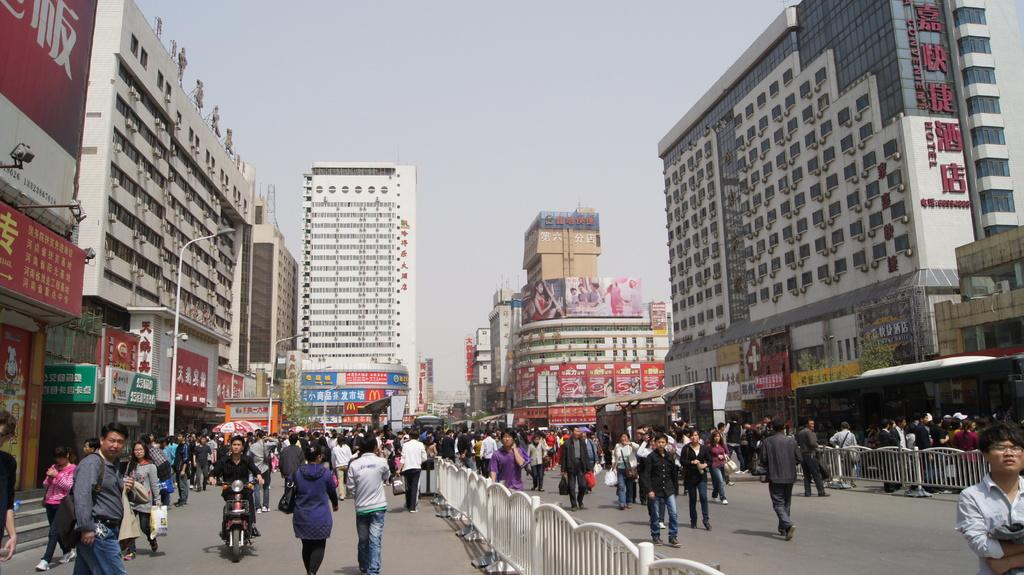What type of structures can be seen in the image? There are buildings in the image. What type of lighting is present in the image? Street lights are present in the image. What type of poles are visible in the image? Street poles are visible in the image. What type of signs are present in the image? Name boards and sign boards are present in the image. What are the people in the image doing? People are standing on the road and sitting on motor vehicles in the image. What type of barrier is visible in the image? Fences are visible in the image. What part of the natural environment is visible in the image? The sky is visible in the image. Can you see any grass growing on the street in the image? There is no grass visible on the street in the image. Is there a ghost haunting the people in the image? There is no ghost present in the image. 